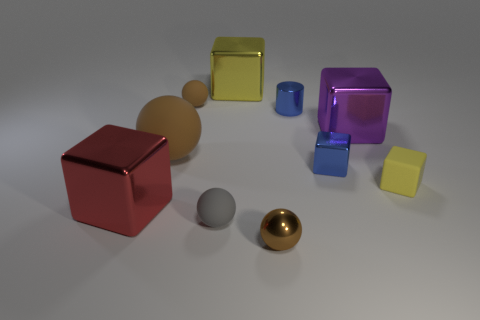Subtract all yellow spheres. How many yellow cubes are left? 2 Subtract all large yellow shiny cubes. How many cubes are left? 4 Subtract 2 spheres. How many spheres are left? 2 Subtract all red blocks. How many blocks are left? 4 Subtract all red cubes. Subtract all cyan spheres. How many cubes are left? 4 Subtract all spheres. How many objects are left? 6 Add 2 big yellow spheres. How many big yellow spheres exist? 2 Subtract 0 yellow cylinders. How many objects are left? 10 Subtract all blue metal objects. Subtract all cylinders. How many objects are left? 7 Add 8 small rubber blocks. How many small rubber blocks are left? 9 